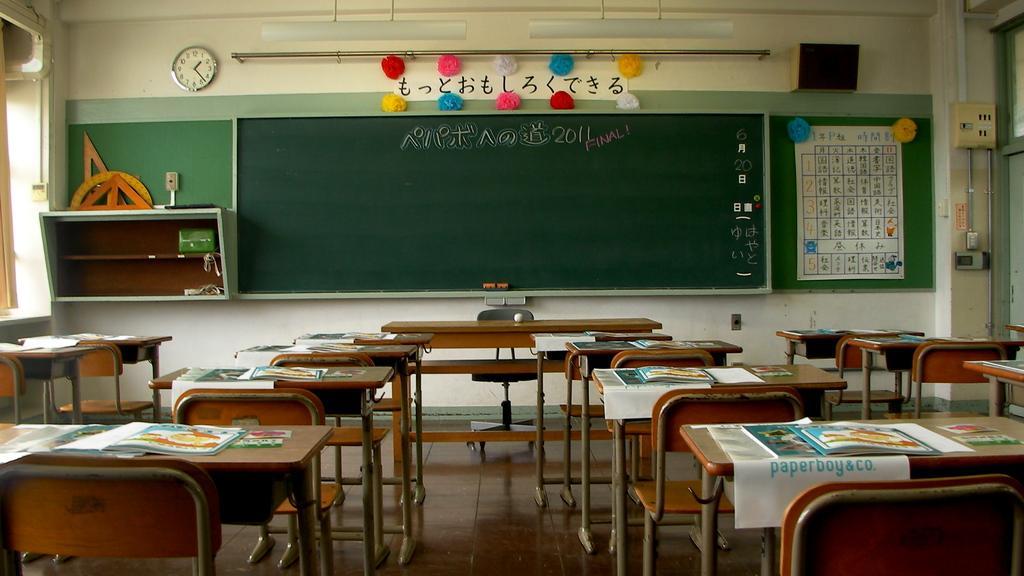Please provide a concise description of this image. In this picture we can see inside view of the classroom. In the front we wooden bench and chairs. Behind we can see green board and calendar. On the top we can see the clock on the yellow wall. 